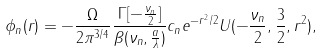Convert formula to latex. <formula><loc_0><loc_0><loc_500><loc_500>\phi _ { n } ( r ) = - \frac { \Omega } { 2 \pi ^ { 3 / 4 } } \frac { \Gamma [ - \frac { \nu _ { n } } { 2 } ] } { \beta ( \nu _ { n } , \frac { a } { \lambda } ) } c _ { n } e ^ { - r ^ { 2 } / 2 } U ( - \frac { \nu _ { n } } { 2 } , \frac { 3 } { 2 } , r ^ { 2 } ) ,</formula> 